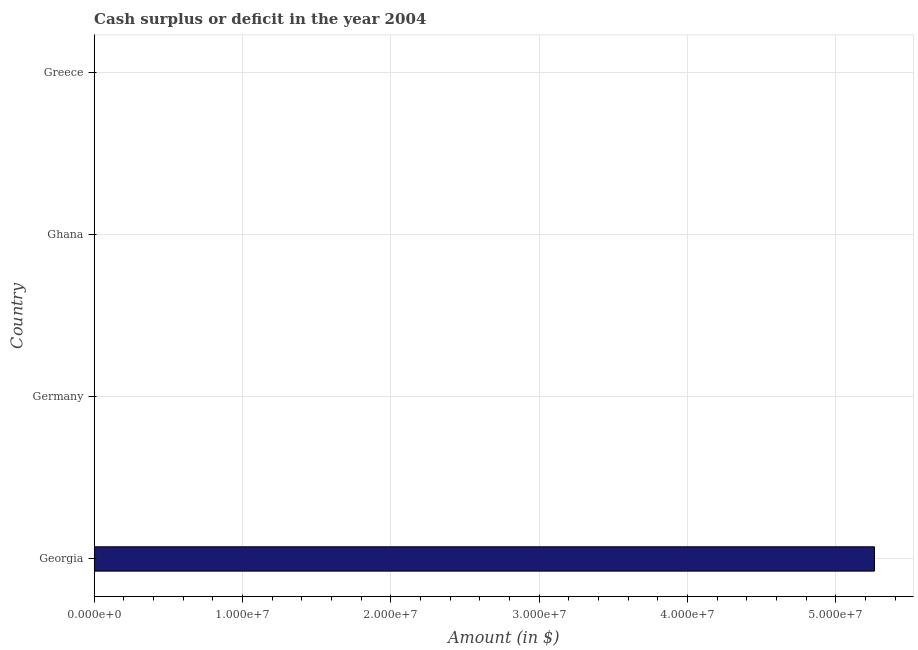Does the graph contain any zero values?
Provide a succinct answer. Yes. Does the graph contain grids?
Offer a terse response. Yes. What is the title of the graph?
Offer a terse response. Cash surplus or deficit in the year 2004. What is the label or title of the X-axis?
Your answer should be very brief. Amount (in $). What is the cash surplus or deficit in Ghana?
Provide a short and direct response. 0. Across all countries, what is the maximum cash surplus or deficit?
Keep it short and to the point. 5.26e+07. In which country was the cash surplus or deficit maximum?
Keep it short and to the point. Georgia. What is the sum of the cash surplus or deficit?
Ensure brevity in your answer.  5.26e+07. What is the average cash surplus or deficit per country?
Ensure brevity in your answer.  1.32e+07. In how many countries, is the cash surplus or deficit greater than 48000000 $?
Provide a short and direct response. 1. What is the difference between the highest and the lowest cash surplus or deficit?
Make the answer very short. 5.26e+07. In how many countries, is the cash surplus or deficit greater than the average cash surplus or deficit taken over all countries?
Offer a very short reply. 1. Are the values on the major ticks of X-axis written in scientific E-notation?
Your answer should be compact. Yes. What is the Amount (in $) of Georgia?
Give a very brief answer. 5.26e+07. What is the Amount (in $) in Germany?
Offer a terse response. 0. 